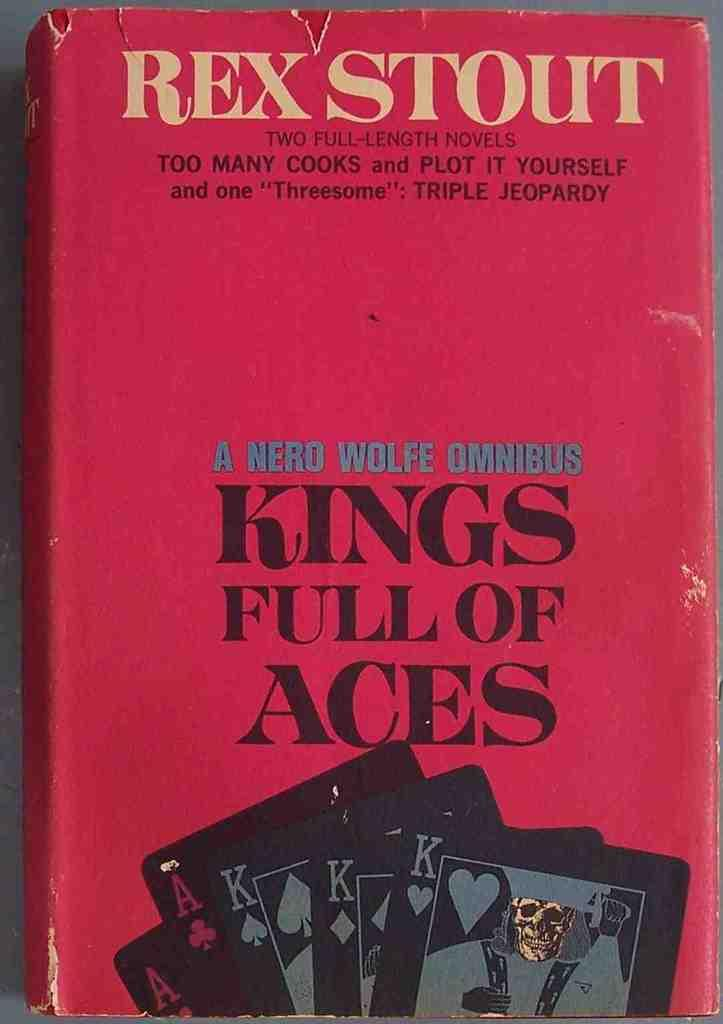<image>
Relay a brief, clear account of the picture shown. A book containing two full-length novels by Rex Stout is titled Kings Full Of Aces. 